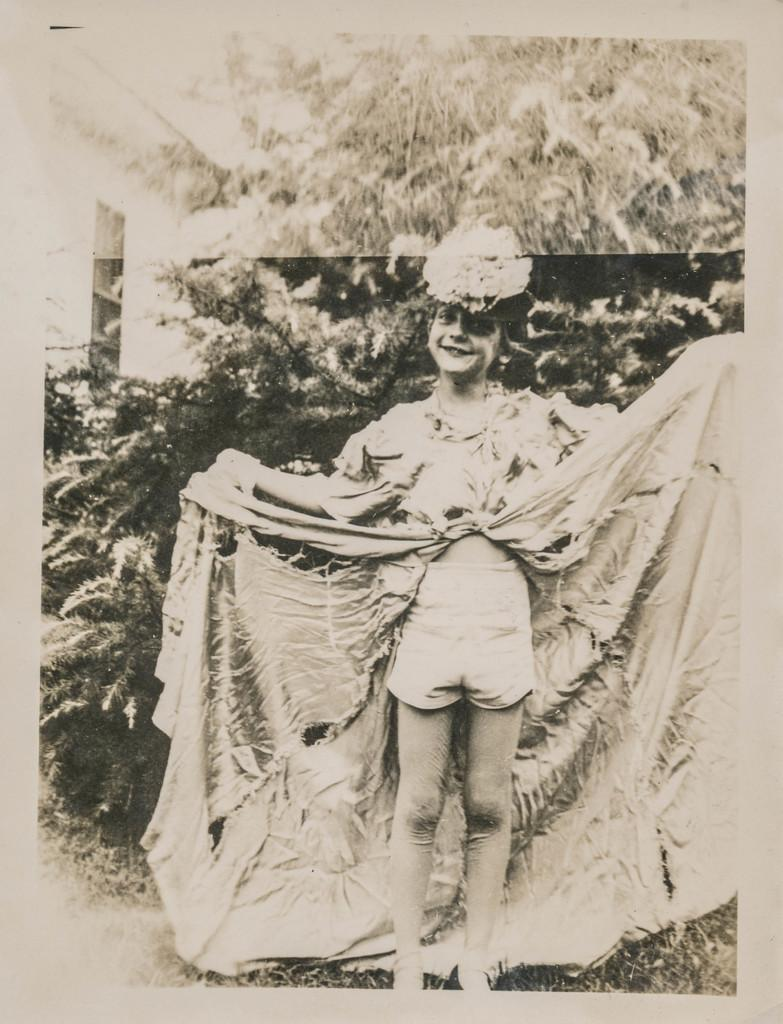Who is present in the image? There is a woman in the image. What is the woman doing in the image? The woman is standing in the image. What is the woman's facial expression in the image? The woman is smiling in the image. What can be seen in the background of the image? There are trees visible in the background of the image. What is the color scheme of the image? The image is black and white. What type of harmony can be heard in the background of the image? There is no sound or music present in the image, so it is not possible to determine what type of harmony might be heard. 